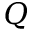<formula> <loc_0><loc_0><loc_500><loc_500>Q</formula> 